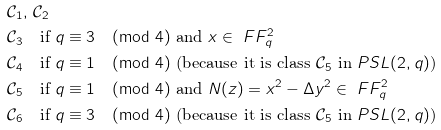<formula> <loc_0><loc_0><loc_500><loc_500>& \mathcal { C } _ { 1 } , \, \mathcal { C } _ { 2 } \\ & \mathcal { C } _ { 3 } \quad \text {if } q \equiv 3 \pmod { 4 } \text { and } x \in \ F F _ { q } ^ { 2 } \\ & \mathcal { C } _ { 4 } \quad \text {if } q \equiv 1 \pmod { 4 } \text { (because it is class $\mathcal{C}_{5}$ in $PSL(2,q)$)} \\ & \mathcal { C } _ { 5 } \quad \text {if } q \equiv 1 \pmod { 4 } \text { and } N ( z ) = x ^ { 2 } - \Delta y ^ { 2 } \in \ F F _ { q } ^ { 2 } \\ & \mathcal { C } _ { 6 } \quad \text {if } q \equiv 3 \pmod { 4 } \text { (because it is class $\mathcal{C}_{5}$ in $PSL(2,q)$)}</formula> 